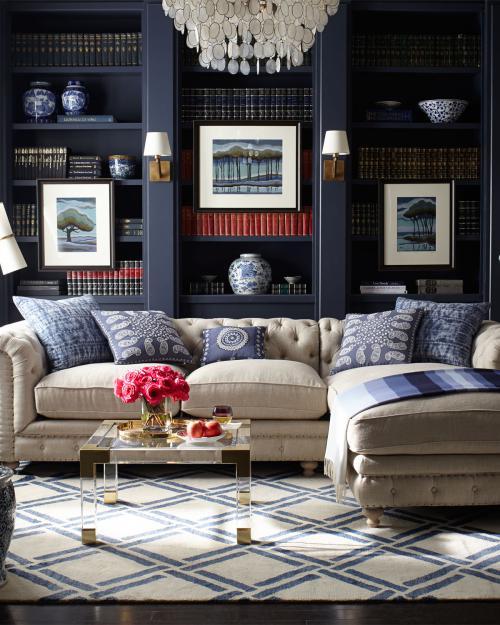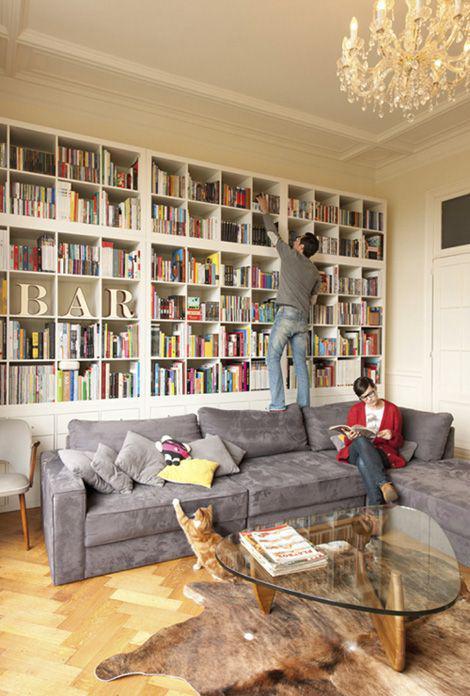The first image is the image on the left, the second image is the image on the right. Given the left and right images, does the statement "There are two lamps with pale shades mounted on the wall behind the couch in one of the images." hold true? Answer yes or no. Yes. The first image is the image on the left, the second image is the image on the right. For the images displayed, is the sentence "in the left image there is a tall window near a book case" factually correct? Answer yes or no. No. 